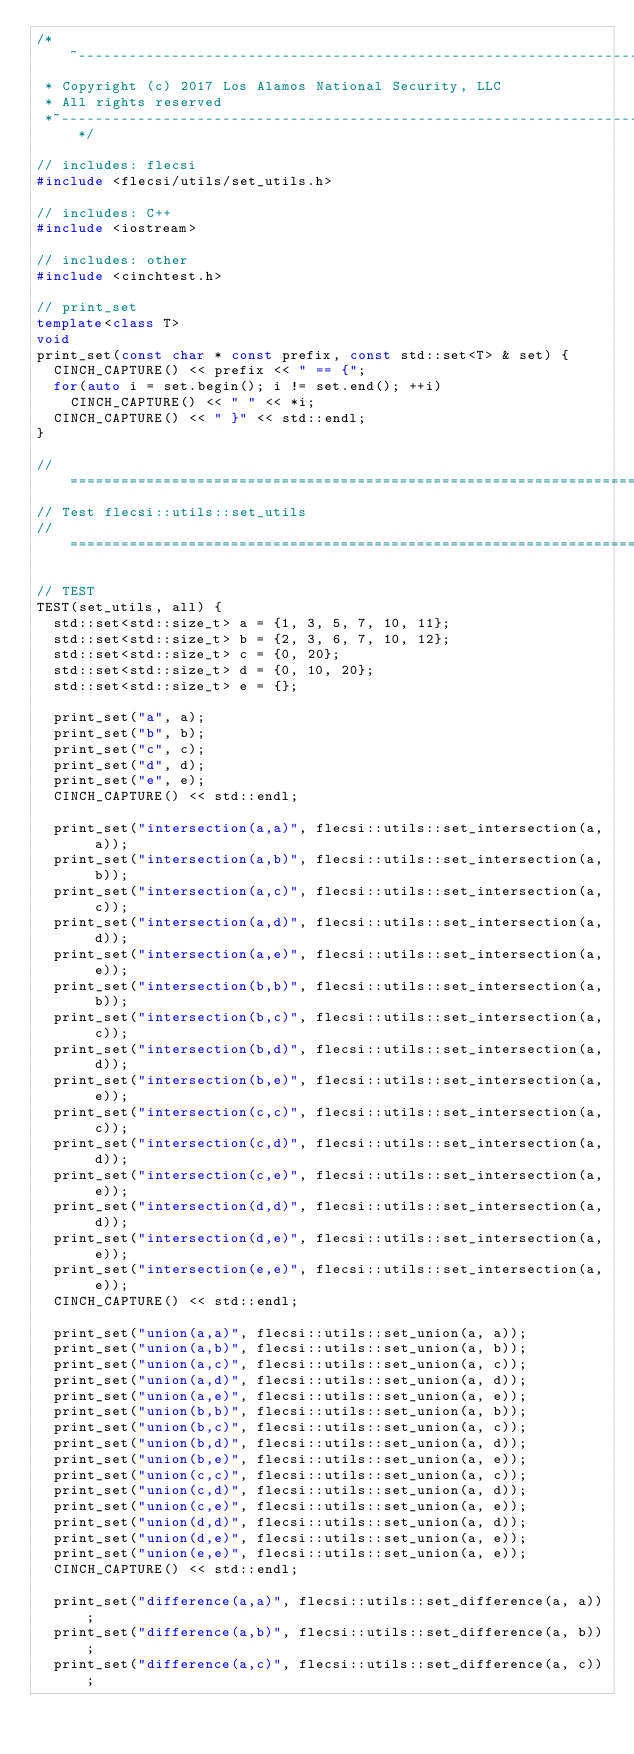<code> <loc_0><loc_0><loc_500><loc_500><_C++_>/*~-------------------------------------------------------------------------~~*
 * Copyright (c) 2017 Los Alamos National Security, LLC
 * All rights reserved
 *~-------------------------------------------------------------------------~~*/

// includes: flecsi
#include <flecsi/utils/set_utils.h>

// includes: C++
#include <iostream>

// includes: other
#include <cinchtest.h>

// print_set
template<class T>
void
print_set(const char * const prefix, const std::set<T> & set) {
  CINCH_CAPTURE() << prefix << " == {";
  for(auto i = set.begin(); i != set.end(); ++i)
    CINCH_CAPTURE() << " " << *i;
  CINCH_CAPTURE() << " }" << std::endl;
}

// =============================================================================
// Test flecsi::utils::set_utils
// =============================================================================

// TEST
TEST(set_utils, all) {
  std::set<std::size_t> a = {1, 3, 5, 7, 10, 11};
  std::set<std::size_t> b = {2, 3, 6, 7, 10, 12};
  std::set<std::size_t> c = {0, 20};
  std::set<std::size_t> d = {0, 10, 20};
  std::set<std::size_t> e = {};

  print_set("a", a);
  print_set("b", b);
  print_set("c", c);
  print_set("d", d);
  print_set("e", e);
  CINCH_CAPTURE() << std::endl;

  print_set("intersection(a,a)", flecsi::utils::set_intersection(a, a));
  print_set("intersection(a,b)", flecsi::utils::set_intersection(a, b));
  print_set("intersection(a,c)", flecsi::utils::set_intersection(a, c));
  print_set("intersection(a,d)", flecsi::utils::set_intersection(a, d));
  print_set("intersection(a,e)", flecsi::utils::set_intersection(a, e));
  print_set("intersection(b,b)", flecsi::utils::set_intersection(a, b));
  print_set("intersection(b,c)", flecsi::utils::set_intersection(a, c));
  print_set("intersection(b,d)", flecsi::utils::set_intersection(a, d));
  print_set("intersection(b,e)", flecsi::utils::set_intersection(a, e));
  print_set("intersection(c,c)", flecsi::utils::set_intersection(a, c));
  print_set("intersection(c,d)", flecsi::utils::set_intersection(a, d));
  print_set("intersection(c,e)", flecsi::utils::set_intersection(a, e));
  print_set("intersection(d,d)", flecsi::utils::set_intersection(a, d));
  print_set("intersection(d,e)", flecsi::utils::set_intersection(a, e));
  print_set("intersection(e,e)", flecsi::utils::set_intersection(a, e));
  CINCH_CAPTURE() << std::endl;

  print_set("union(a,a)", flecsi::utils::set_union(a, a));
  print_set("union(a,b)", flecsi::utils::set_union(a, b));
  print_set("union(a,c)", flecsi::utils::set_union(a, c));
  print_set("union(a,d)", flecsi::utils::set_union(a, d));
  print_set("union(a,e)", flecsi::utils::set_union(a, e));
  print_set("union(b,b)", flecsi::utils::set_union(a, b));
  print_set("union(b,c)", flecsi::utils::set_union(a, c));
  print_set("union(b,d)", flecsi::utils::set_union(a, d));
  print_set("union(b,e)", flecsi::utils::set_union(a, e));
  print_set("union(c,c)", flecsi::utils::set_union(a, c));
  print_set("union(c,d)", flecsi::utils::set_union(a, d));
  print_set("union(c,e)", flecsi::utils::set_union(a, e));
  print_set("union(d,d)", flecsi::utils::set_union(a, d));
  print_set("union(d,e)", flecsi::utils::set_union(a, e));
  print_set("union(e,e)", flecsi::utils::set_union(a, e));
  CINCH_CAPTURE() << std::endl;

  print_set("difference(a,a)", flecsi::utils::set_difference(a, a));
  print_set("difference(a,b)", flecsi::utils::set_difference(a, b));
  print_set("difference(a,c)", flecsi::utils::set_difference(a, c));</code> 